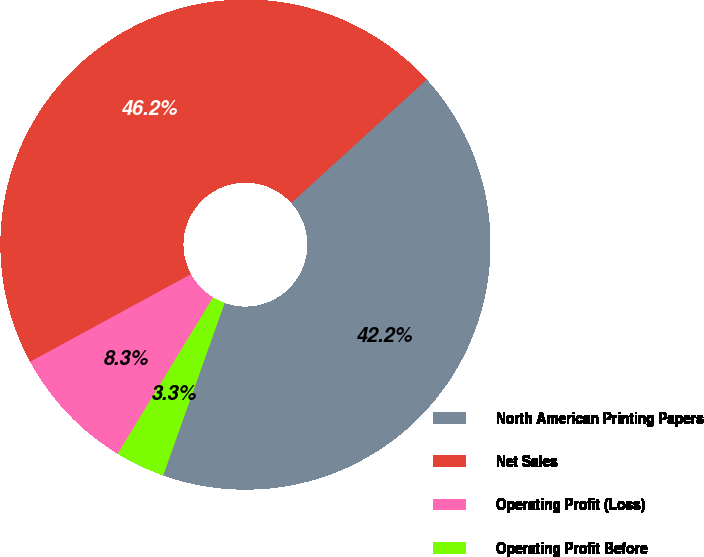Convert chart. <chart><loc_0><loc_0><loc_500><loc_500><pie_chart><fcel>North American Printing Papers<fcel>Net Sales<fcel>Operating Profit (Loss)<fcel>Operating Profit Before<nl><fcel>42.21%<fcel>46.18%<fcel>8.34%<fcel>3.27%<nl></chart> 